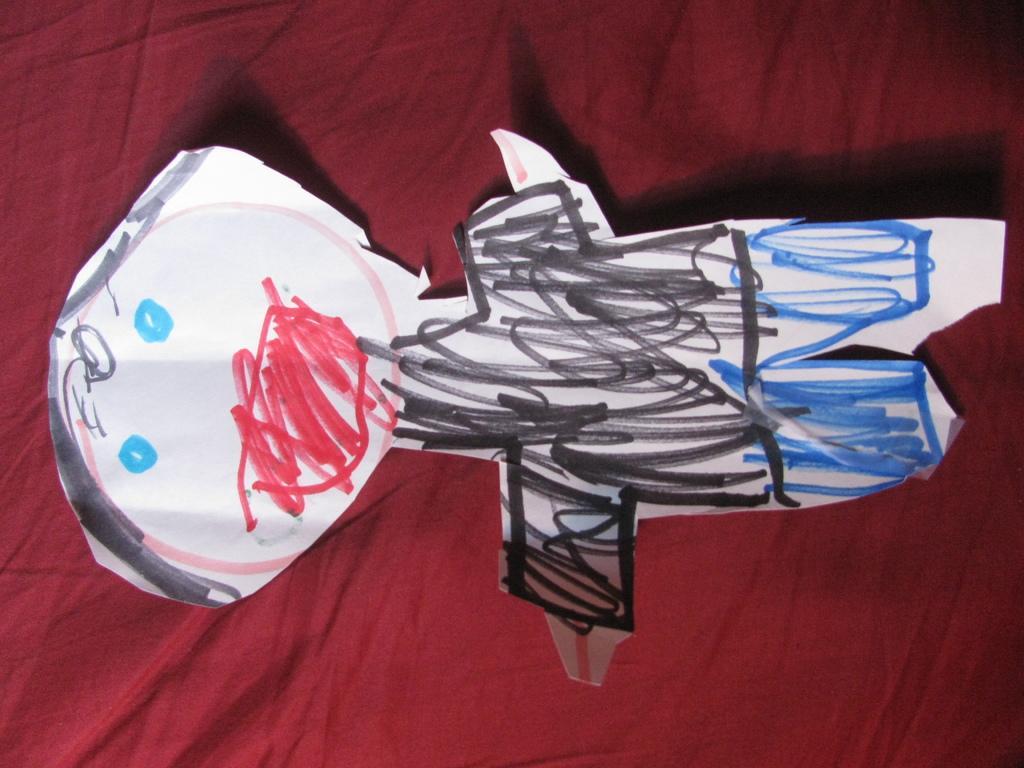Please provide a concise description of this image. A drawing is made on a paper. There is a maroon surface. 